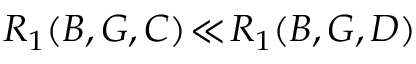<formula> <loc_0><loc_0><loc_500><loc_500>R _ { 1 } ( B , G , C ) \, \ll \, R _ { 1 } ( B , G , D )</formula> 